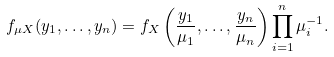<formula> <loc_0><loc_0><loc_500><loc_500>f _ { \mu X } ( y _ { 1 } , \dots , y _ { n } ) = f _ { X } \left ( \frac { y _ { 1 } } { \mu _ { 1 } } , \dots , \frac { y _ { n } } { \mu _ { n } } \right ) \prod _ { i = 1 } ^ { n } \mu _ { i } ^ { - 1 } .</formula> 